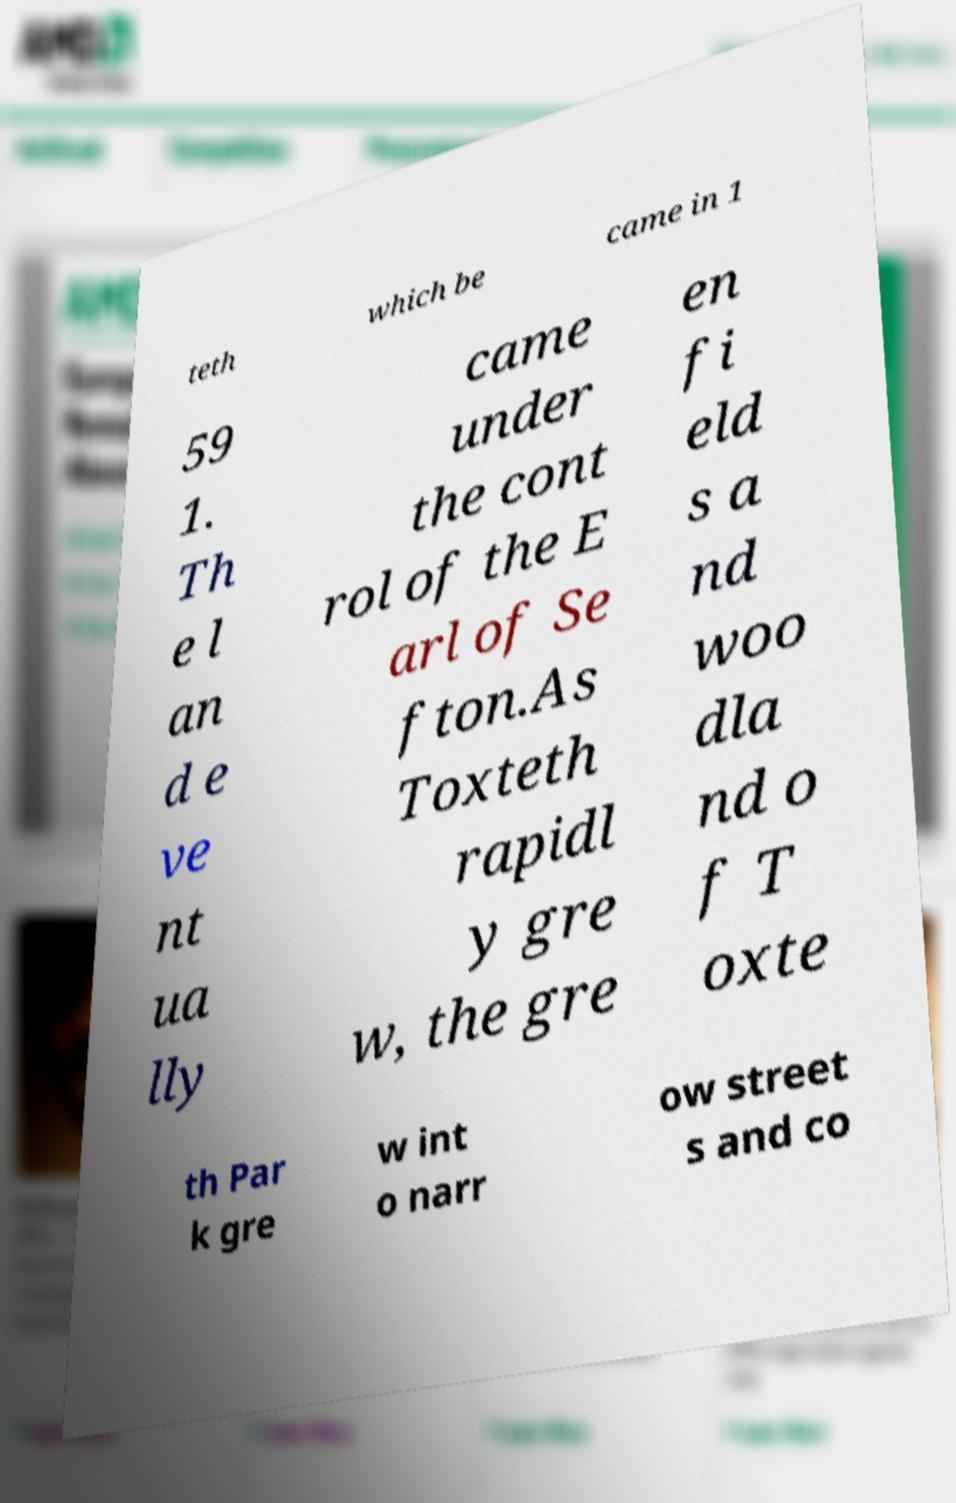What messages or text are displayed in this image? I need them in a readable, typed format. teth which be came in 1 59 1. Th e l an d e ve nt ua lly came under the cont rol of the E arl of Se fton.As Toxteth rapidl y gre w, the gre en fi eld s a nd woo dla nd o f T oxte th Par k gre w int o narr ow street s and co 